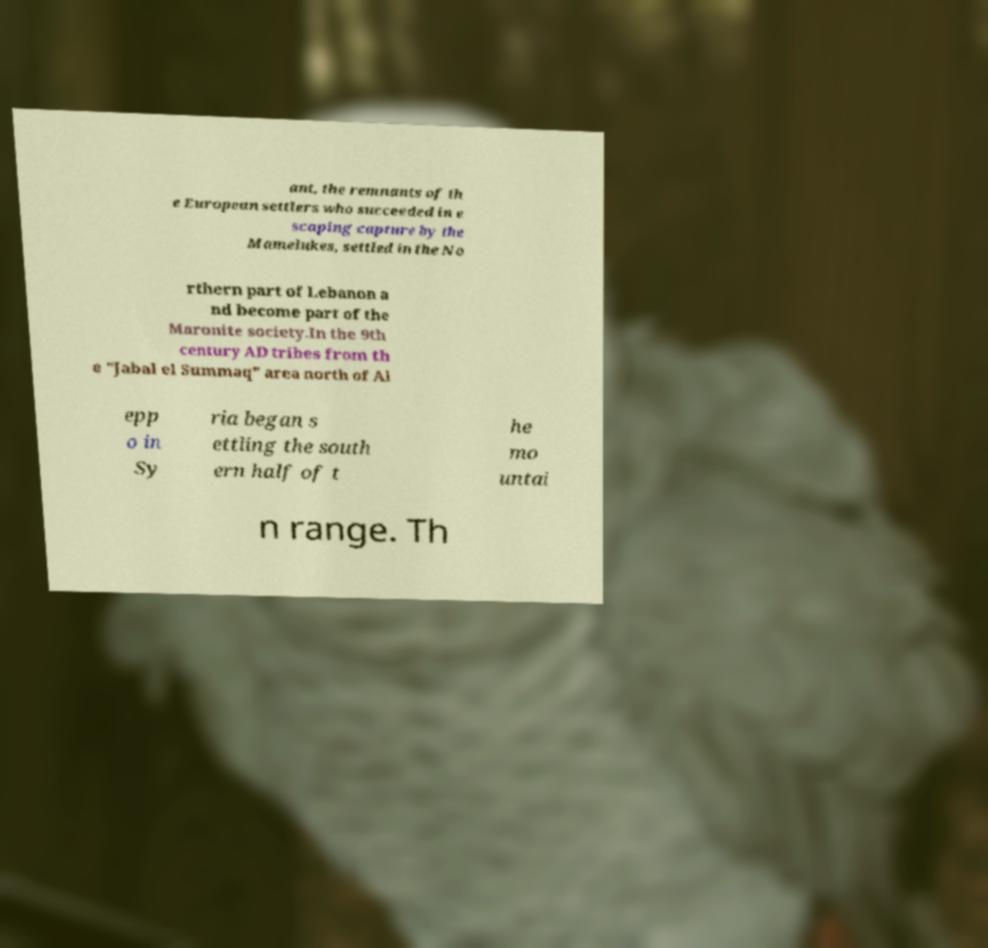For documentation purposes, I need the text within this image transcribed. Could you provide that? ant, the remnants of th e European settlers who succeeded in e scaping capture by the Mamelukes, settled in the No rthern part of Lebanon a nd become part of the Maronite society.In the 9th century AD tribes from th e "Jabal el Summaq" area north of Al epp o in Sy ria began s ettling the south ern half of t he mo untai n range. Th 